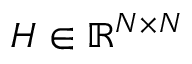<formula> <loc_0><loc_0><loc_500><loc_500>H \in \mathbb { R } ^ { N \times N }</formula> 